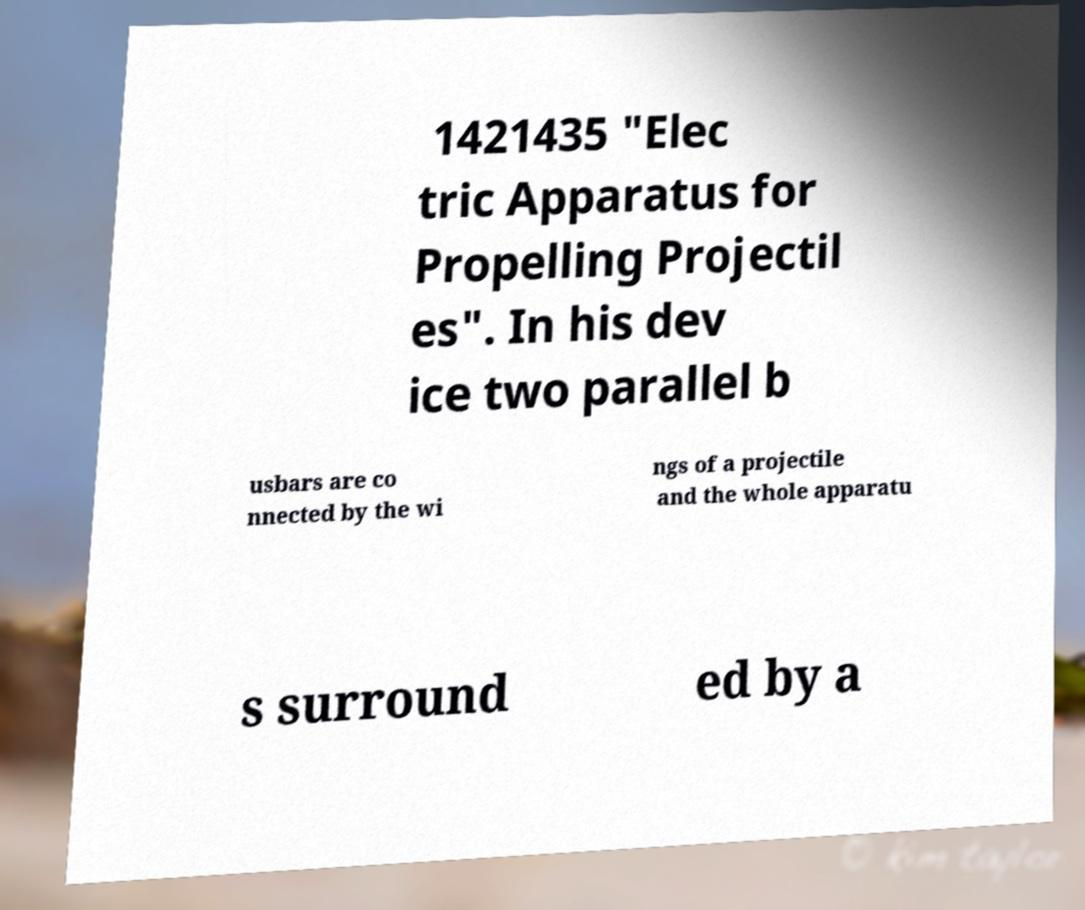I need the written content from this picture converted into text. Can you do that? 1421435 "Elec tric Apparatus for Propelling Projectil es". In his dev ice two parallel b usbars are co nnected by the wi ngs of a projectile and the whole apparatu s surround ed by a 